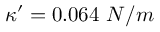Convert formula to latex. <formula><loc_0><loc_0><loc_500><loc_500>\kappa ^ { \prime } = 0 . 0 6 4 \ N / m</formula> 